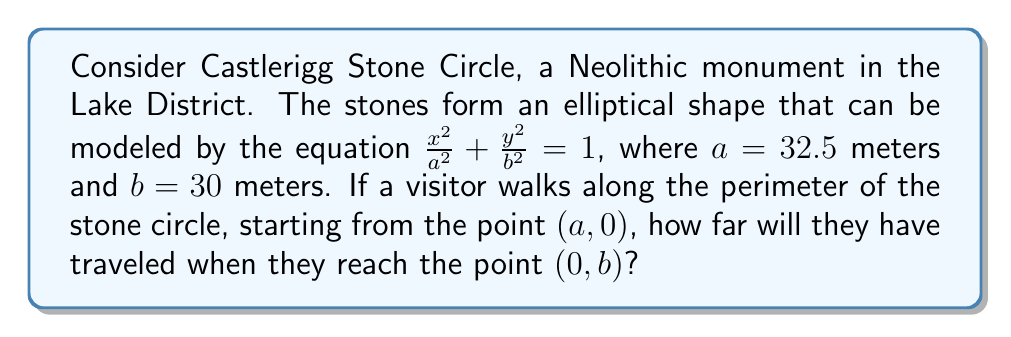Help me with this question. To solve this problem, we need to use the arc length formula for an ellipse, which is a nonlinear equation. Let's approach this step-by-step:

1) The arc length of an ellipse from $\theta = 0$ to $\theta = \frac{\pi}{2}$ (quarter of the ellipse) is given by the integral:

   $$L = a \int_0^{\frac{\pi}{2}} \sqrt{1 - e^2 \sin^2 \theta} \, d\theta$$

   where $e$ is the eccentricity of the ellipse.

2) The eccentricity $e$ is calculated as:

   $$e = \sqrt{1 - \frac{b^2}{a^2}} = \sqrt{1 - \frac{30^2}{32.5^2}} \approx 0.3780$$

3) Substituting the values:

   $$L = 32.5 \int_0^{\frac{\pi}{2}} \sqrt{1 - (0.3780)^2 \sin^2 \theta} \, d\theta$$

4) This integral doesn't have an elementary antiderivative. It's an elliptic integral of the second kind, which is typically solved numerically or approximated.

5) Using numerical integration methods (e.g., Simpson's rule or adaptive quadrature), we can evaluate this integral:

   $$L \approx 49.3219 \text{ meters}$$

This is the distance along the ellipse from $(a, 0)$ to $(0, b)$, which represents a quarter of the total circumference.
Answer: $49.3219$ meters 